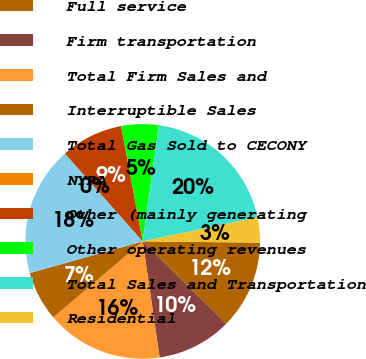<chart> <loc_0><loc_0><loc_500><loc_500><pie_chart><fcel>Full service<fcel>Firm transportation<fcel>Total Firm Sales and<fcel>Interruptible Sales<fcel>Total Gas Sold to CECONY<fcel>NYPA<fcel>Other (mainly generating<fcel>Other operating revenues<fcel>Total Sales and Transportation<fcel>Residential<nl><fcel>12.23%<fcel>10.3%<fcel>16.09%<fcel>6.87%<fcel>17.8%<fcel>0.02%<fcel>8.58%<fcel>5.16%<fcel>19.51%<fcel>3.45%<nl></chart> 